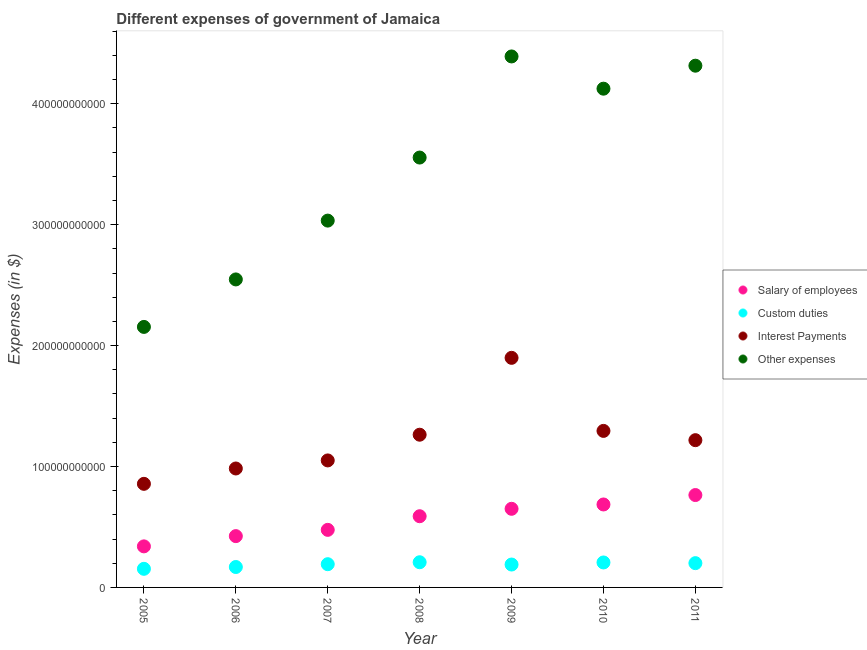How many different coloured dotlines are there?
Offer a very short reply. 4. Is the number of dotlines equal to the number of legend labels?
Offer a terse response. Yes. What is the amount spent on salary of employees in 2009?
Keep it short and to the point. 6.50e+1. Across all years, what is the maximum amount spent on other expenses?
Your response must be concise. 4.39e+11. Across all years, what is the minimum amount spent on interest payments?
Give a very brief answer. 8.57e+1. What is the total amount spent on interest payments in the graph?
Offer a very short reply. 8.56e+11. What is the difference between the amount spent on salary of employees in 2006 and that in 2011?
Your response must be concise. -3.40e+1. What is the difference between the amount spent on custom duties in 2010 and the amount spent on salary of employees in 2006?
Your answer should be compact. -2.18e+1. What is the average amount spent on salary of employees per year?
Give a very brief answer. 5.61e+1. In the year 2010, what is the difference between the amount spent on salary of employees and amount spent on other expenses?
Your answer should be compact. -3.44e+11. What is the ratio of the amount spent on interest payments in 2009 to that in 2011?
Give a very brief answer. 1.56. Is the difference between the amount spent on other expenses in 2007 and 2008 greater than the difference between the amount spent on salary of employees in 2007 and 2008?
Your answer should be compact. No. What is the difference between the highest and the second highest amount spent on custom duties?
Ensure brevity in your answer.  1.80e+08. What is the difference between the highest and the lowest amount spent on other expenses?
Offer a terse response. 2.24e+11. In how many years, is the amount spent on custom duties greater than the average amount spent on custom duties taken over all years?
Provide a succinct answer. 5. Is it the case that in every year, the sum of the amount spent on salary of employees and amount spent on custom duties is greater than the amount spent on interest payments?
Provide a succinct answer. No. Is the amount spent on other expenses strictly greater than the amount spent on custom duties over the years?
Your response must be concise. Yes. How many years are there in the graph?
Your answer should be compact. 7. What is the difference between two consecutive major ticks on the Y-axis?
Provide a succinct answer. 1.00e+11. Does the graph contain any zero values?
Ensure brevity in your answer.  No. How are the legend labels stacked?
Make the answer very short. Vertical. What is the title of the graph?
Your answer should be compact. Different expenses of government of Jamaica. What is the label or title of the X-axis?
Give a very brief answer. Year. What is the label or title of the Y-axis?
Your answer should be compact. Expenses (in $). What is the Expenses (in $) in Salary of employees in 2005?
Offer a very short reply. 3.39e+1. What is the Expenses (in $) of Custom duties in 2005?
Give a very brief answer. 1.54e+1. What is the Expenses (in $) in Interest Payments in 2005?
Ensure brevity in your answer.  8.57e+1. What is the Expenses (in $) in Other expenses in 2005?
Ensure brevity in your answer.  2.15e+11. What is the Expenses (in $) in Salary of employees in 2006?
Offer a very short reply. 4.24e+1. What is the Expenses (in $) in Custom duties in 2006?
Offer a terse response. 1.69e+1. What is the Expenses (in $) in Interest Payments in 2006?
Offer a very short reply. 9.84e+1. What is the Expenses (in $) of Other expenses in 2006?
Your answer should be very brief. 2.55e+11. What is the Expenses (in $) of Salary of employees in 2007?
Provide a short and direct response. 4.76e+1. What is the Expenses (in $) in Custom duties in 2007?
Your response must be concise. 1.92e+1. What is the Expenses (in $) of Interest Payments in 2007?
Your response must be concise. 1.05e+11. What is the Expenses (in $) of Other expenses in 2007?
Keep it short and to the point. 3.03e+11. What is the Expenses (in $) of Salary of employees in 2008?
Your response must be concise. 5.89e+1. What is the Expenses (in $) in Custom duties in 2008?
Make the answer very short. 2.08e+1. What is the Expenses (in $) of Interest Payments in 2008?
Your answer should be compact. 1.26e+11. What is the Expenses (in $) in Other expenses in 2008?
Give a very brief answer. 3.55e+11. What is the Expenses (in $) in Salary of employees in 2009?
Your answer should be compact. 6.50e+1. What is the Expenses (in $) in Custom duties in 2009?
Provide a short and direct response. 1.89e+1. What is the Expenses (in $) of Interest Payments in 2009?
Your response must be concise. 1.90e+11. What is the Expenses (in $) of Other expenses in 2009?
Offer a terse response. 4.39e+11. What is the Expenses (in $) in Salary of employees in 2010?
Offer a terse response. 6.86e+1. What is the Expenses (in $) of Custom duties in 2010?
Your answer should be compact. 2.06e+1. What is the Expenses (in $) of Interest Payments in 2010?
Offer a very short reply. 1.29e+11. What is the Expenses (in $) in Other expenses in 2010?
Your response must be concise. 4.12e+11. What is the Expenses (in $) of Salary of employees in 2011?
Your answer should be compact. 7.64e+1. What is the Expenses (in $) in Custom duties in 2011?
Provide a short and direct response. 2.01e+1. What is the Expenses (in $) in Interest Payments in 2011?
Offer a very short reply. 1.22e+11. What is the Expenses (in $) in Other expenses in 2011?
Offer a terse response. 4.31e+11. Across all years, what is the maximum Expenses (in $) of Salary of employees?
Provide a short and direct response. 7.64e+1. Across all years, what is the maximum Expenses (in $) of Custom duties?
Make the answer very short. 2.08e+1. Across all years, what is the maximum Expenses (in $) in Interest Payments?
Make the answer very short. 1.90e+11. Across all years, what is the maximum Expenses (in $) in Other expenses?
Make the answer very short. 4.39e+11. Across all years, what is the minimum Expenses (in $) in Salary of employees?
Your response must be concise. 3.39e+1. Across all years, what is the minimum Expenses (in $) in Custom duties?
Make the answer very short. 1.54e+1. Across all years, what is the minimum Expenses (in $) in Interest Payments?
Ensure brevity in your answer.  8.57e+1. Across all years, what is the minimum Expenses (in $) in Other expenses?
Provide a succinct answer. 2.15e+11. What is the total Expenses (in $) in Salary of employees in the graph?
Offer a terse response. 3.93e+11. What is the total Expenses (in $) of Custom duties in the graph?
Your response must be concise. 1.32e+11. What is the total Expenses (in $) in Interest Payments in the graph?
Offer a terse response. 8.56e+11. What is the total Expenses (in $) in Other expenses in the graph?
Keep it short and to the point. 2.41e+12. What is the difference between the Expenses (in $) of Salary of employees in 2005 and that in 2006?
Provide a short and direct response. -8.48e+09. What is the difference between the Expenses (in $) of Custom duties in 2005 and that in 2006?
Make the answer very short. -1.49e+09. What is the difference between the Expenses (in $) of Interest Payments in 2005 and that in 2006?
Offer a terse response. -1.27e+1. What is the difference between the Expenses (in $) of Other expenses in 2005 and that in 2006?
Provide a short and direct response. -3.93e+1. What is the difference between the Expenses (in $) in Salary of employees in 2005 and that in 2007?
Your answer should be compact. -1.37e+1. What is the difference between the Expenses (in $) of Custom duties in 2005 and that in 2007?
Your answer should be very brief. -3.82e+09. What is the difference between the Expenses (in $) of Interest Payments in 2005 and that in 2007?
Keep it short and to the point. -1.94e+1. What is the difference between the Expenses (in $) of Other expenses in 2005 and that in 2007?
Your answer should be very brief. -8.79e+1. What is the difference between the Expenses (in $) in Salary of employees in 2005 and that in 2008?
Offer a very short reply. -2.49e+1. What is the difference between the Expenses (in $) in Custom duties in 2005 and that in 2008?
Your response must be concise. -5.44e+09. What is the difference between the Expenses (in $) in Interest Payments in 2005 and that in 2008?
Provide a succinct answer. -4.06e+1. What is the difference between the Expenses (in $) in Other expenses in 2005 and that in 2008?
Make the answer very short. -1.40e+11. What is the difference between the Expenses (in $) in Salary of employees in 2005 and that in 2009?
Your answer should be very brief. -3.11e+1. What is the difference between the Expenses (in $) in Custom duties in 2005 and that in 2009?
Provide a succinct answer. -3.54e+09. What is the difference between the Expenses (in $) of Interest Payments in 2005 and that in 2009?
Your answer should be compact. -1.04e+11. What is the difference between the Expenses (in $) of Other expenses in 2005 and that in 2009?
Ensure brevity in your answer.  -2.24e+11. What is the difference between the Expenses (in $) of Salary of employees in 2005 and that in 2010?
Your answer should be compact. -3.47e+1. What is the difference between the Expenses (in $) in Custom duties in 2005 and that in 2010?
Provide a succinct answer. -5.26e+09. What is the difference between the Expenses (in $) of Interest Payments in 2005 and that in 2010?
Your answer should be very brief. -4.38e+1. What is the difference between the Expenses (in $) of Other expenses in 2005 and that in 2010?
Give a very brief answer. -1.97e+11. What is the difference between the Expenses (in $) of Salary of employees in 2005 and that in 2011?
Your answer should be compact. -4.24e+1. What is the difference between the Expenses (in $) in Custom duties in 2005 and that in 2011?
Your response must be concise. -4.69e+09. What is the difference between the Expenses (in $) in Interest Payments in 2005 and that in 2011?
Ensure brevity in your answer.  -3.61e+1. What is the difference between the Expenses (in $) of Other expenses in 2005 and that in 2011?
Offer a terse response. -2.16e+11. What is the difference between the Expenses (in $) in Salary of employees in 2006 and that in 2007?
Your answer should be compact. -5.18e+09. What is the difference between the Expenses (in $) in Custom duties in 2006 and that in 2007?
Give a very brief answer. -2.33e+09. What is the difference between the Expenses (in $) of Interest Payments in 2006 and that in 2007?
Provide a succinct answer. -6.67e+09. What is the difference between the Expenses (in $) of Other expenses in 2006 and that in 2007?
Offer a terse response. -4.86e+1. What is the difference between the Expenses (in $) in Salary of employees in 2006 and that in 2008?
Give a very brief answer. -1.64e+1. What is the difference between the Expenses (in $) of Custom duties in 2006 and that in 2008?
Ensure brevity in your answer.  -3.94e+09. What is the difference between the Expenses (in $) in Interest Payments in 2006 and that in 2008?
Your answer should be compact. -2.79e+1. What is the difference between the Expenses (in $) of Other expenses in 2006 and that in 2008?
Your answer should be compact. -1.01e+11. What is the difference between the Expenses (in $) in Salary of employees in 2006 and that in 2009?
Keep it short and to the point. -2.26e+1. What is the difference between the Expenses (in $) of Custom duties in 2006 and that in 2009?
Ensure brevity in your answer.  -2.05e+09. What is the difference between the Expenses (in $) of Interest Payments in 2006 and that in 2009?
Your answer should be compact. -9.15e+1. What is the difference between the Expenses (in $) in Other expenses in 2006 and that in 2009?
Your answer should be very brief. -1.84e+11. What is the difference between the Expenses (in $) in Salary of employees in 2006 and that in 2010?
Offer a very short reply. -2.62e+1. What is the difference between the Expenses (in $) in Custom duties in 2006 and that in 2010?
Your answer should be very brief. -3.76e+09. What is the difference between the Expenses (in $) in Interest Payments in 2006 and that in 2010?
Your answer should be compact. -3.11e+1. What is the difference between the Expenses (in $) in Other expenses in 2006 and that in 2010?
Offer a terse response. -1.58e+11. What is the difference between the Expenses (in $) in Salary of employees in 2006 and that in 2011?
Provide a short and direct response. -3.40e+1. What is the difference between the Expenses (in $) of Custom duties in 2006 and that in 2011?
Offer a very short reply. -3.19e+09. What is the difference between the Expenses (in $) of Interest Payments in 2006 and that in 2011?
Offer a very short reply. -2.34e+1. What is the difference between the Expenses (in $) in Other expenses in 2006 and that in 2011?
Give a very brief answer. -1.77e+11. What is the difference between the Expenses (in $) in Salary of employees in 2007 and that in 2008?
Ensure brevity in your answer.  -1.13e+1. What is the difference between the Expenses (in $) of Custom duties in 2007 and that in 2008?
Your answer should be very brief. -1.62e+09. What is the difference between the Expenses (in $) of Interest Payments in 2007 and that in 2008?
Your answer should be compact. -2.13e+1. What is the difference between the Expenses (in $) in Other expenses in 2007 and that in 2008?
Provide a short and direct response. -5.21e+1. What is the difference between the Expenses (in $) in Salary of employees in 2007 and that in 2009?
Give a very brief answer. -1.74e+1. What is the difference between the Expenses (in $) of Custom duties in 2007 and that in 2009?
Make the answer very short. 2.75e+08. What is the difference between the Expenses (in $) of Interest Payments in 2007 and that in 2009?
Ensure brevity in your answer.  -8.48e+1. What is the difference between the Expenses (in $) in Other expenses in 2007 and that in 2009?
Give a very brief answer. -1.36e+11. What is the difference between the Expenses (in $) of Salary of employees in 2007 and that in 2010?
Offer a very short reply. -2.10e+1. What is the difference between the Expenses (in $) of Custom duties in 2007 and that in 2010?
Offer a very short reply. -1.44e+09. What is the difference between the Expenses (in $) of Interest Payments in 2007 and that in 2010?
Offer a terse response. -2.44e+1. What is the difference between the Expenses (in $) of Other expenses in 2007 and that in 2010?
Offer a terse response. -1.09e+11. What is the difference between the Expenses (in $) of Salary of employees in 2007 and that in 2011?
Offer a terse response. -2.88e+1. What is the difference between the Expenses (in $) of Custom duties in 2007 and that in 2011?
Ensure brevity in your answer.  -8.66e+08. What is the difference between the Expenses (in $) of Interest Payments in 2007 and that in 2011?
Provide a succinct answer. -1.67e+1. What is the difference between the Expenses (in $) of Other expenses in 2007 and that in 2011?
Provide a short and direct response. -1.28e+11. What is the difference between the Expenses (in $) in Salary of employees in 2008 and that in 2009?
Your answer should be very brief. -6.14e+09. What is the difference between the Expenses (in $) of Custom duties in 2008 and that in 2009?
Offer a terse response. 1.89e+09. What is the difference between the Expenses (in $) of Interest Payments in 2008 and that in 2009?
Provide a succinct answer. -6.36e+1. What is the difference between the Expenses (in $) of Other expenses in 2008 and that in 2009?
Make the answer very short. -8.36e+1. What is the difference between the Expenses (in $) of Salary of employees in 2008 and that in 2010?
Your answer should be very brief. -9.73e+09. What is the difference between the Expenses (in $) in Custom duties in 2008 and that in 2010?
Make the answer very short. 1.80e+08. What is the difference between the Expenses (in $) in Interest Payments in 2008 and that in 2010?
Offer a terse response. -3.15e+09. What is the difference between the Expenses (in $) in Other expenses in 2008 and that in 2010?
Your answer should be very brief. -5.69e+1. What is the difference between the Expenses (in $) of Salary of employees in 2008 and that in 2011?
Give a very brief answer. -1.75e+1. What is the difference between the Expenses (in $) in Custom duties in 2008 and that in 2011?
Offer a terse response. 7.50e+08. What is the difference between the Expenses (in $) in Interest Payments in 2008 and that in 2011?
Ensure brevity in your answer.  4.51e+09. What is the difference between the Expenses (in $) of Other expenses in 2008 and that in 2011?
Make the answer very short. -7.60e+1. What is the difference between the Expenses (in $) of Salary of employees in 2009 and that in 2010?
Ensure brevity in your answer.  -3.59e+09. What is the difference between the Expenses (in $) in Custom duties in 2009 and that in 2010?
Your answer should be very brief. -1.71e+09. What is the difference between the Expenses (in $) in Interest Payments in 2009 and that in 2010?
Give a very brief answer. 6.04e+1. What is the difference between the Expenses (in $) in Other expenses in 2009 and that in 2010?
Ensure brevity in your answer.  2.67e+1. What is the difference between the Expenses (in $) in Salary of employees in 2009 and that in 2011?
Ensure brevity in your answer.  -1.14e+1. What is the difference between the Expenses (in $) in Custom duties in 2009 and that in 2011?
Your answer should be compact. -1.14e+09. What is the difference between the Expenses (in $) in Interest Payments in 2009 and that in 2011?
Offer a very short reply. 6.81e+1. What is the difference between the Expenses (in $) in Other expenses in 2009 and that in 2011?
Keep it short and to the point. 7.65e+09. What is the difference between the Expenses (in $) in Salary of employees in 2010 and that in 2011?
Make the answer very short. -7.79e+09. What is the difference between the Expenses (in $) in Custom duties in 2010 and that in 2011?
Your answer should be compact. 5.70e+08. What is the difference between the Expenses (in $) of Interest Payments in 2010 and that in 2011?
Your answer should be compact. 7.67e+09. What is the difference between the Expenses (in $) of Other expenses in 2010 and that in 2011?
Your response must be concise. -1.90e+1. What is the difference between the Expenses (in $) in Salary of employees in 2005 and the Expenses (in $) in Custom duties in 2006?
Give a very brief answer. 1.71e+1. What is the difference between the Expenses (in $) in Salary of employees in 2005 and the Expenses (in $) in Interest Payments in 2006?
Provide a succinct answer. -6.44e+1. What is the difference between the Expenses (in $) of Salary of employees in 2005 and the Expenses (in $) of Other expenses in 2006?
Ensure brevity in your answer.  -2.21e+11. What is the difference between the Expenses (in $) in Custom duties in 2005 and the Expenses (in $) in Interest Payments in 2006?
Your response must be concise. -8.30e+1. What is the difference between the Expenses (in $) of Custom duties in 2005 and the Expenses (in $) of Other expenses in 2006?
Provide a short and direct response. -2.39e+11. What is the difference between the Expenses (in $) of Interest Payments in 2005 and the Expenses (in $) of Other expenses in 2006?
Give a very brief answer. -1.69e+11. What is the difference between the Expenses (in $) of Salary of employees in 2005 and the Expenses (in $) of Custom duties in 2007?
Make the answer very short. 1.47e+1. What is the difference between the Expenses (in $) in Salary of employees in 2005 and the Expenses (in $) in Interest Payments in 2007?
Make the answer very short. -7.11e+1. What is the difference between the Expenses (in $) of Salary of employees in 2005 and the Expenses (in $) of Other expenses in 2007?
Your answer should be very brief. -2.69e+11. What is the difference between the Expenses (in $) of Custom duties in 2005 and the Expenses (in $) of Interest Payments in 2007?
Your answer should be very brief. -8.96e+1. What is the difference between the Expenses (in $) of Custom duties in 2005 and the Expenses (in $) of Other expenses in 2007?
Keep it short and to the point. -2.88e+11. What is the difference between the Expenses (in $) in Interest Payments in 2005 and the Expenses (in $) in Other expenses in 2007?
Provide a short and direct response. -2.18e+11. What is the difference between the Expenses (in $) of Salary of employees in 2005 and the Expenses (in $) of Custom duties in 2008?
Provide a succinct answer. 1.31e+1. What is the difference between the Expenses (in $) in Salary of employees in 2005 and the Expenses (in $) in Interest Payments in 2008?
Give a very brief answer. -9.23e+1. What is the difference between the Expenses (in $) in Salary of employees in 2005 and the Expenses (in $) in Other expenses in 2008?
Give a very brief answer. -3.22e+11. What is the difference between the Expenses (in $) of Custom duties in 2005 and the Expenses (in $) of Interest Payments in 2008?
Offer a very short reply. -1.11e+11. What is the difference between the Expenses (in $) in Custom duties in 2005 and the Expenses (in $) in Other expenses in 2008?
Make the answer very short. -3.40e+11. What is the difference between the Expenses (in $) in Interest Payments in 2005 and the Expenses (in $) in Other expenses in 2008?
Provide a succinct answer. -2.70e+11. What is the difference between the Expenses (in $) of Salary of employees in 2005 and the Expenses (in $) of Custom duties in 2009?
Ensure brevity in your answer.  1.50e+1. What is the difference between the Expenses (in $) of Salary of employees in 2005 and the Expenses (in $) of Interest Payments in 2009?
Your response must be concise. -1.56e+11. What is the difference between the Expenses (in $) in Salary of employees in 2005 and the Expenses (in $) in Other expenses in 2009?
Offer a very short reply. -4.05e+11. What is the difference between the Expenses (in $) of Custom duties in 2005 and the Expenses (in $) of Interest Payments in 2009?
Give a very brief answer. -1.74e+11. What is the difference between the Expenses (in $) in Custom duties in 2005 and the Expenses (in $) in Other expenses in 2009?
Provide a short and direct response. -4.24e+11. What is the difference between the Expenses (in $) in Interest Payments in 2005 and the Expenses (in $) in Other expenses in 2009?
Your answer should be very brief. -3.53e+11. What is the difference between the Expenses (in $) in Salary of employees in 2005 and the Expenses (in $) in Custom duties in 2010?
Your answer should be compact. 1.33e+1. What is the difference between the Expenses (in $) in Salary of employees in 2005 and the Expenses (in $) in Interest Payments in 2010?
Make the answer very short. -9.55e+1. What is the difference between the Expenses (in $) of Salary of employees in 2005 and the Expenses (in $) of Other expenses in 2010?
Make the answer very short. -3.78e+11. What is the difference between the Expenses (in $) of Custom duties in 2005 and the Expenses (in $) of Interest Payments in 2010?
Offer a very short reply. -1.14e+11. What is the difference between the Expenses (in $) of Custom duties in 2005 and the Expenses (in $) of Other expenses in 2010?
Your response must be concise. -3.97e+11. What is the difference between the Expenses (in $) in Interest Payments in 2005 and the Expenses (in $) in Other expenses in 2010?
Your answer should be compact. -3.27e+11. What is the difference between the Expenses (in $) of Salary of employees in 2005 and the Expenses (in $) of Custom duties in 2011?
Provide a short and direct response. 1.39e+1. What is the difference between the Expenses (in $) in Salary of employees in 2005 and the Expenses (in $) in Interest Payments in 2011?
Provide a succinct answer. -8.78e+1. What is the difference between the Expenses (in $) of Salary of employees in 2005 and the Expenses (in $) of Other expenses in 2011?
Provide a short and direct response. -3.97e+11. What is the difference between the Expenses (in $) of Custom duties in 2005 and the Expenses (in $) of Interest Payments in 2011?
Your answer should be compact. -1.06e+11. What is the difference between the Expenses (in $) in Custom duties in 2005 and the Expenses (in $) in Other expenses in 2011?
Your answer should be very brief. -4.16e+11. What is the difference between the Expenses (in $) in Interest Payments in 2005 and the Expenses (in $) in Other expenses in 2011?
Offer a terse response. -3.46e+11. What is the difference between the Expenses (in $) of Salary of employees in 2006 and the Expenses (in $) of Custom duties in 2007?
Your answer should be very brief. 2.32e+1. What is the difference between the Expenses (in $) of Salary of employees in 2006 and the Expenses (in $) of Interest Payments in 2007?
Keep it short and to the point. -6.26e+1. What is the difference between the Expenses (in $) of Salary of employees in 2006 and the Expenses (in $) of Other expenses in 2007?
Offer a very short reply. -2.61e+11. What is the difference between the Expenses (in $) of Custom duties in 2006 and the Expenses (in $) of Interest Payments in 2007?
Provide a succinct answer. -8.81e+1. What is the difference between the Expenses (in $) in Custom duties in 2006 and the Expenses (in $) in Other expenses in 2007?
Your answer should be very brief. -2.86e+11. What is the difference between the Expenses (in $) in Interest Payments in 2006 and the Expenses (in $) in Other expenses in 2007?
Your answer should be very brief. -2.05e+11. What is the difference between the Expenses (in $) of Salary of employees in 2006 and the Expenses (in $) of Custom duties in 2008?
Make the answer very short. 2.16e+1. What is the difference between the Expenses (in $) of Salary of employees in 2006 and the Expenses (in $) of Interest Payments in 2008?
Your answer should be very brief. -8.39e+1. What is the difference between the Expenses (in $) in Salary of employees in 2006 and the Expenses (in $) in Other expenses in 2008?
Your answer should be very brief. -3.13e+11. What is the difference between the Expenses (in $) of Custom duties in 2006 and the Expenses (in $) of Interest Payments in 2008?
Your response must be concise. -1.09e+11. What is the difference between the Expenses (in $) of Custom duties in 2006 and the Expenses (in $) of Other expenses in 2008?
Keep it short and to the point. -3.39e+11. What is the difference between the Expenses (in $) in Interest Payments in 2006 and the Expenses (in $) in Other expenses in 2008?
Your answer should be compact. -2.57e+11. What is the difference between the Expenses (in $) of Salary of employees in 2006 and the Expenses (in $) of Custom duties in 2009?
Ensure brevity in your answer.  2.35e+1. What is the difference between the Expenses (in $) of Salary of employees in 2006 and the Expenses (in $) of Interest Payments in 2009?
Your answer should be compact. -1.47e+11. What is the difference between the Expenses (in $) of Salary of employees in 2006 and the Expenses (in $) of Other expenses in 2009?
Your answer should be compact. -3.97e+11. What is the difference between the Expenses (in $) of Custom duties in 2006 and the Expenses (in $) of Interest Payments in 2009?
Your answer should be compact. -1.73e+11. What is the difference between the Expenses (in $) of Custom duties in 2006 and the Expenses (in $) of Other expenses in 2009?
Offer a very short reply. -4.22e+11. What is the difference between the Expenses (in $) of Interest Payments in 2006 and the Expenses (in $) of Other expenses in 2009?
Your answer should be compact. -3.41e+11. What is the difference between the Expenses (in $) in Salary of employees in 2006 and the Expenses (in $) in Custom duties in 2010?
Offer a very short reply. 2.18e+1. What is the difference between the Expenses (in $) in Salary of employees in 2006 and the Expenses (in $) in Interest Payments in 2010?
Provide a short and direct response. -8.70e+1. What is the difference between the Expenses (in $) in Salary of employees in 2006 and the Expenses (in $) in Other expenses in 2010?
Your answer should be very brief. -3.70e+11. What is the difference between the Expenses (in $) in Custom duties in 2006 and the Expenses (in $) in Interest Payments in 2010?
Your response must be concise. -1.13e+11. What is the difference between the Expenses (in $) in Custom duties in 2006 and the Expenses (in $) in Other expenses in 2010?
Your answer should be compact. -3.96e+11. What is the difference between the Expenses (in $) of Interest Payments in 2006 and the Expenses (in $) of Other expenses in 2010?
Give a very brief answer. -3.14e+11. What is the difference between the Expenses (in $) in Salary of employees in 2006 and the Expenses (in $) in Custom duties in 2011?
Offer a terse response. 2.24e+1. What is the difference between the Expenses (in $) in Salary of employees in 2006 and the Expenses (in $) in Interest Payments in 2011?
Offer a terse response. -7.93e+1. What is the difference between the Expenses (in $) of Salary of employees in 2006 and the Expenses (in $) of Other expenses in 2011?
Your response must be concise. -3.89e+11. What is the difference between the Expenses (in $) of Custom duties in 2006 and the Expenses (in $) of Interest Payments in 2011?
Provide a succinct answer. -1.05e+11. What is the difference between the Expenses (in $) of Custom duties in 2006 and the Expenses (in $) of Other expenses in 2011?
Ensure brevity in your answer.  -4.15e+11. What is the difference between the Expenses (in $) in Interest Payments in 2006 and the Expenses (in $) in Other expenses in 2011?
Give a very brief answer. -3.33e+11. What is the difference between the Expenses (in $) in Salary of employees in 2007 and the Expenses (in $) in Custom duties in 2008?
Your answer should be compact. 2.68e+1. What is the difference between the Expenses (in $) of Salary of employees in 2007 and the Expenses (in $) of Interest Payments in 2008?
Provide a succinct answer. -7.87e+1. What is the difference between the Expenses (in $) in Salary of employees in 2007 and the Expenses (in $) in Other expenses in 2008?
Make the answer very short. -3.08e+11. What is the difference between the Expenses (in $) in Custom duties in 2007 and the Expenses (in $) in Interest Payments in 2008?
Offer a very short reply. -1.07e+11. What is the difference between the Expenses (in $) of Custom duties in 2007 and the Expenses (in $) of Other expenses in 2008?
Offer a very short reply. -3.36e+11. What is the difference between the Expenses (in $) in Interest Payments in 2007 and the Expenses (in $) in Other expenses in 2008?
Make the answer very short. -2.50e+11. What is the difference between the Expenses (in $) in Salary of employees in 2007 and the Expenses (in $) in Custom duties in 2009?
Your answer should be compact. 2.87e+1. What is the difference between the Expenses (in $) in Salary of employees in 2007 and the Expenses (in $) in Interest Payments in 2009?
Keep it short and to the point. -1.42e+11. What is the difference between the Expenses (in $) of Salary of employees in 2007 and the Expenses (in $) of Other expenses in 2009?
Keep it short and to the point. -3.91e+11. What is the difference between the Expenses (in $) in Custom duties in 2007 and the Expenses (in $) in Interest Payments in 2009?
Ensure brevity in your answer.  -1.71e+11. What is the difference between the Expenses (in $) in Custom duties in 2007 and the Expenses (in $) in Other expenses in 2009?
Ensure brevity in your answer.  -4.20e+11. What is the difference between the Expenses (in $) of Interest Payments in 2007 and the Expenses (in $) of Other expenses in 2009?
Your answer should be very brief. -3.34e+11. What is the difference between the Expenses (in $) of Salary of employees in 2007 and the Expenses (in $) of Custom duties in 2010?
Make the answer very short. 2.70e+1. What is the difference between the Expenses (in $) of Salary of employees in 2007 and the Expenses (in $) of Interest Payments in 2010?
Provide a succinct answer. -8.18e+1. What is the difference between the Expenses (in $) in Salary of employees in 2007 and the Expenses (in $) in Other expenses in 2010?
Your answer should be compact. -3.65e+11. What is the difference between the Expenses (in $) of Custom duties in 2007 and the Expenses (in $) of Interest Payments in 2010?
Ensure brevity in your answer.  -1.10e+11. What is the difference between the Expenses (in $) of Custom duties in 2007 and the Expenses (in $) of Other expenses in 2010?
Your answer should be very brief. -3.93e+11. What is the difference between the Expenses (in $) in Interest Payments in 2007 and the Expenses (in $) in Other expenses in 2010?
Offer a very short reply. -3.07e+11. What is the difference between the Expenses (in $) in Salary of employees in 2007 and the Expenses (in $) in Custom duties in 2011?
Provide a short and direct response. 2.75e+1. What is the difference between the Expenses (in $) of Salary of employees in 2007 and the Expenses (in $) of Interest Payments in 2011?
Keep it short and to the point. -7.42e+1. What is the difference between the Expenses (in $) in Salary of employees in 2007 and the Expenses (in $) in Other expenses in 2011?
Give a very brief answer. -3.84e+11. What is the difference between the Expenses (in $) of Custom duties in 2007 and the Expenses (in $) of Interest Payments in 2011?
Offer a terse response. -1.03e+11. What is the difference between the Expenses (in $) in Custom duties in 2007 and the Expenses (in $) in Other expenses in 2011?
Ensure brevity in your answer.  -4.12e+11. What is the difference between the Expenses (in $) in Interest Payments in 2007 and the Expenses (in $) in Other expenses in 2011?
Keep it short and to the point. -3.26e+11. What is the difference between the Expenses (in $) in Salary of employees in 2008 and the Expenses (in $) in Custom duties in 2009?
Provide a succinct answer. 3.99e+1. What is the difference between the Expenses (in $) of Salary of employees in 2008 and the Expenses (in $) of Interest Payments in 2009?
Offer a terse response. -1.31e+11. What is the difference between the Expenses (in $) of Salary of employees in 2008 and the Expenses (in $) of Other expenses in 2009?
Ensure brevity in your answer.  -3.80e+11. What is the difference between the Expenses (in $) in Custom duties in 2008 and the Expenses (in $) in Interest Payments in 2009?
Give a very brief answer. -1.69e+11. What is the difference between the Expenses (in $) in Custom duties in 2008 and the Expenses (in $) in Other expenses in 2009?
Make the answer very short. -4.18e+11. What is the difference between the Expenses (in $) in Interest Payments in 2008 and the Expenses (in $) in Other expenses in 2009?
Provide a succinct answer. -3.13e+11. What is the difference between the Expenses (in $) in Salary of employees in 2008 and the Expenses (in $) in Custom duties in 2010?
Give a very brief answer. 3.82e+1. What is the difference between the Expenses (in $) of Salary of employees in 2008 and the Expenses (in $) of Interest Payments in 2010?
Provide a succinct answer. -7.06e+1. What is the difference between the Expenses (in $) of Salary of employees in 2008 and the Expenses (in $) of Other expenses in 2010?
Make the answer very short. -3.54e+11. What is the difference between the Expenses (in $) of Custom duties in 2008 and the Expenses (in $) of Interest Payments in 2010?
Provide a succinct answer. -1.09e+11. What is the difference between the Expenses (in $) of Custom duties in 2008 and the Expenses (in $) of Other expenses in 2010?
Provide a short and direct response. -3.92e+11. What is the difference between the Expenses (in $) in Interest Payments in 2008 and the Expenses (in $) in Other expenses in 2010?
Provide a succinct answer. -2.86e+11. What is the difference between the Expenses (in $) in Salary of employees in 2008 and the Expenses (in $) in Custom duties in 2011?
Offer a very short reply. 3.88e+1. What is the difference between the Expenses (in $) of Salary of employees in 2008 and the Expenses (in $) of Interest Payments in 2011?
Make the answer very short. -6.29e+1. What is the difference between the Expenses (in $) in Salary of employees in 2008 and the Expenses (in $) in Other expenses in 2011?
Offer a very short reply. -3.73e+11. What is the difference between the Expenses (in $) of Custom duties in 2008 and the Expenses (in $) of Interest Payments in 2011?
Provide a succinct answer. -1.01e+11. What is the difference between the Expenses (in $) in Custom duties in 2008 and the Expenses (in $) in Other expenses in 2011?
Your response must be concise. -4.11e+11. What is the difference between the Expenses (in $) in Interest Payments in 2008 and the Expenses (in $) in Other expenses in 2011?
Keep it short and to the point. -3.05e+11. What is the difference between the Expenses (in $) in Salary of employees in 2009 and the Expenses (in $) in Custom duties in 2010?
Offer a terse response. 4.44e+1. What is the difference between the Expenses (in $) of Salary of employees in 2009 and the Expenses (in $) of Interest Payments in 2010?
Give a very brief answer. -6.44e+1. What is the difference between the Expenses (in $) of Salary of employees in 2009 and the Expenses (in $) of Other expenses in 2010?
Make the answer very short. -3.47e+11. What is the difference between the Expenses (in $) in Custom duties in 2009 and the Expenses (in $) in Interest Payments in 2010?
Offer a very short reply. -1.11e+11. What is the difference between the Expenses (in $) of Custom duties in 2009 and the Expenses (in $) of Other expenses in 2010?
Offer a terse response. -3.93e+11. What is the difference between the Expenses (in $) in Interest Payments in 2009 and the Expenses (in $) in Other expenses in 2010?
Make the answer very short. -2.23e+11. What is the difference between the Expenses (in $) in Salary of employees in 2009 and the Expenses (in $) in Custom duties in 2011?
Ensure brevity in your answer.  4.49e+1. What is the difference between the Expenses (in $) in Salary of employees in 2009 and the Expenses (in $) in Interest Payments in 2011?
Your response must be concise. -5.68e+1. What is the difference between the Expenses (in $) of Salary of employees in 2009 and the Expenses (in $) of Other expenses in 2011?
Your answer should be compact. -3.66e+11. What is the difference between the Expenses (in $) in Custom duties in 2009 and the Expenses (in $) in Interest Payments in 2011?
Offer a terse response. -1.03e+11. What is the difference between the Expenses (in $) in Custom duties in 2009 and the Expenses (in $) in Other expenses in 2011?
Make the answer very short. -4.13e+11. What is the difference between the Expenses (in $) in Interest Payments in 2009 and the Expenses (in $) in Other expenses in 2011?
Ensure brevity in your answer.  -2.42e+11. What is the difference between the Expenses (in $) in Salary of employees in 2010 and the Expenses (in $) in Custom duties in 2011?
Your answer should be very brief. 4.85e+1. What is the difference between the Expenses (in $) in Salary of employees in 2010 and the Expenses (in $) in Interest Payments in 2011?
Your answer should be very brief. -5.32e+1. What is the difference between the Expenses (in $) in Salary of employees in 2010 and the Expenses (in $) in Other expenses in 2011?
Provide a succinct answer. -3.63e+11. What is the difference between the Expenses (in $) of Custom duties in 2010 and the Expenses (in $) of Interest Payments in 2011?
Ensure brevity in your answer.  -1.01e+11. What is the difference between the Expenses (in $) of Custom duties in 2010 and the Expenses (in $) of Other expenses in 2011?
Offer a terse response. -4.11e+11. What is the difference between the Expenses (in $) of Interest Payments in 2010 and the Expenses (in $) of Other expenses in 2011?
Provide a succinct answer. -3.02e+11. What is the average Expenses (in $) in Salary of employees per year?
Offer a terse response. 5.61e+1. What is the average Expenses (in $) in Custom duties per year?
Make the answer very short. 1.88e+1. What is the average Expenses (in $) of Interest Payments per year?
Make the answer very short. 1.22e+11. What is the average Expenses (in $) in Other expenses per year?
Make the answer very short. 3.45e+11. In the year 2005, what is the difference between the Expenses (in $) in Salary of employees and Expenses (in $) in Custom duties?
Offer a terse response. 1.86e+1. In the year 2005, what is the difference between the Expenses (in $) in Salary of employees and Expenses (in $) in Interest Payments?
Make the answer very short. -5.17e+1. In the year 2005, what is the difference between the Expenses (in $) in Salary of employees and Expenses (in $) in Other expenses?
Your answer should be compact. -1.81e+11. In the year 2005, what is the difference between the Expenses (in $) in Custom duties and Expenses (in $) in Interest Payments?
Keep it short and to the point. -7.03e+1. In the year 2005, what is the difference between the Expenses (in $) of Custom duties and Expenses (in $) of Other expenses?
Keep it short and to the point. -2.00e+11. In the year 2005, what is the difference between the Expenses (in $) in Interest Payments and Expenses (in $) in Other expenses?
Ensure brevity in your answer.  -1.30e+11. In the year 2006, what is the difference between the Expenses (in $) in Salary of employees and Expenses (in $) in Custom duties?
Offer a terse response. 2.55e+1. In the year 2006, what is the difference between the Expenses (in $) in Salary of employees and Expenses (in $) in Interest Payments?
Offer a terse response. -5.59e+1. In the year 2006, what is the difference between the Expenses (in $) of Salary of employees and Expenses (in $) of Other expenses?
Give a very brief answer. -2.12e+11. In the year 2006, what is the difference between the Expenses (in $) of Custom duties and Expenses (in $) of Interest Payments?
Keep it short and to the point. -8.15e+1. In the year 2006, what is the difference between the Expenses (in $) of Custom duties and Expenses (in $) of Other expenses?
Your response must be concise. -2.38e+11. In the year 2006, what is the difference between the Expenses (in $) in Interest Payments and Expenses (in $) in Other expenses?
Keep it short and to the point. -1.56e+11. In the year 2007, what is the difference between the Expenses (in $) of Salary of employees and Expenses (in $) of Custom duties?
Ensure brevity in your answer.  2.84e+1. In the year 2007, what is the difference between the Expenses (in $) in Salary of employees and Expenses (in $) in Interest Payments?
Your answer should be very brief. -5.74e+1. In the year 2007, what is the difference between the Expenses (in $) of Salary of employees and Expenses (in $) of Other expenses?
Your answer should be compact. -2.56e+11. In the year 2007, what is the difference between the Expenses (in $) in Custom duties and Expenses (in $) in Interest Payments?
Offer a terse response. -8.58e+1. In the year 2007, what is the difference between the Expenses (in $) in Custom duties and Expenses (in $) in Other expenses?
Provide a short and direct response. -2.84e+11. In the year 2007, what is the difference between the Expenses (in $) of Interest Payments and Expenses (in $) of Other expenses?
Keep it short and to the point. -1.98e+11. In the year 2008, what is the difference between the Expenses (in $) in Salary of employees and Expenses (in $) in Custom duties?
Your answer should be very brief. 3.81e+1. In the year 2008, what is the difference between the Expenses (in $) in Salary of employees and Expenses (in $) in Interest Payments?
Offer a very short reply. -6.74e+1. In the year 2008, what is the difference between the Expenses (in $) of Salary of employees and Expenses (in $) of Other expenses?
Ensure brevity in your answer.  -2.97e+11. In the year 2008, what is the difference between the Expenses (in $) in Custom duties and Expenses (in $) in Interest Payments?
Give a very brief answer. -1.05e+11. In the year 2008, what is the difference between the Expenses (in $) in Custom duties and Expenses (in $) in Other expenses?
Provide a succinct answer. -3.35e+11. In the year 2008, what is the difference between the Expenses (in $) in Interest Payments and Expenses (in $) in Other expenses?
Offer a terse response. -2.29e+11. In the year 2009, what is the difference between the Expenses (in $) in Salary of employees and Expenses (in $) in Custom duties?
Ensure brevity in your answer.  4.61e+1. In the year 2009, what is the difference between the Expenses (in $) in Salary of employees and Expenses (in $) in Interest Payments?
Offer a very short reply. -1.25e+11. In the year 2009, what is the difference between the Expenses (in $) of Salary of employees and Expenses (in $) of Other expenses?
Your response must be concise. -3.74e+11. In the year 2009, what is the difference between the Expenses (in $) of Custom duties and Expenses (in $) of Interest Payments?
Provide a short and direct response. -1.71e+11. In the year 2009, what is the difference between the Expenses (in $) in Custom duties and Expenses (in $) in Other expenses?
Offer a terse response. -4.20e+11. In the year 2009, what is the difference between the Expenses (in $) of Interest Payments and Expenses (in $) of Other expenses?
Provide a short and direct response. -2.49e+11. In the year 2010, what is the difference between the Expenses (in $) in Salary of employees and Expenses (in $) in Custom duties?
Keep it short and to the point. 4.80e+1. In the year 2010, what is the difference between the Expenses (in $) in Salary of employees and Expenses (in $) in Interest Payments?
Make the answer very short. -6.08e+1. In the year 2010, what is the difference between the Expenses (in $) of Salary of employees and Expenses (in $) of Other expenses?
Your response must be concise. -3.44e+11. In the year 2010, what is the difference between the Expenses (in $) of Custom duties and Expenses (in $) of Interest Payments?
Make the answer very short. -1.09e+11. In the year 2010, what is the difference between the Expenses (in $) in Custom duties and Expenses (in $) in Other expenses?
Give a very brief answer. -3.92e+11. In the year 2010, what is the difference between the Expenses (in $) in Interest Payments and Expenses (in $) in Other expenses?
Keep it short and to the point. -2.83e+11. In the year 2011, what is the difference between the Expenses (in $) in Salary of employees and Expenses (in $) in Custom duties?
Your answer should be compact. 5.63e+1. In the year 2011, what is the difference between the Expenses (in $) in Salary of employees and Expenses (in $) in Interest Payments?
Your answer should be compact. -4.54e+1. In the year 2011, what is the difference between the Expenses (in $) in Salary of employees and Expenses (in $) in Other expenses?
Provide a short and direct response. -3.55e+11. In the year 2011, what is the difference between the Expenses (in $) in Custom duties and Expenses (in $) in Interest Payments?
Provide a succinct answer. -1.02e+11. In the year 2011, what is the difference between the Expenses (in $) of Custom duties and Expenses (in $) of Other expenses?
Keep it short and to the point. -4.11e+11. In the year 2011, what is the difference between the Expenses (in $) in Interest Payments and Expenses (in $) in Other expenses?
Ensure brevity in your answer.  -3.10e+11. What is the ratio of the Expenses (in $) of Salary of employees in 2005 to that in 2006?
Your answer should be very brief. 0.8. What is the ratio of the Expenses (in $) in Custom duties in 2005 to that in 2006?
Provide a succinct answer. 0.91. What is the ratio of the Expenses (in $) in Interest Payments in 2005 to that in 2006?
Keep it short and to the point. 0.87. What is the ratio of the Expenses (in $) of Other expenses in 2005 to that in 2006?
Your answer should be compact. 0.85. What is the ratio of the Expenses (in $) in Salary of employees in 2005 to that in 2007?
Provide a short and direct response. 0.71. What is the ratio of the Expenses (in $) of Custom duties in 2005 to that in 2007?
Provide a short and direct response. 0.8. What is the ratio of the Expenses (in $) in Interest Payments in 2005 to that in 2007?
Your answer should be very brief. 0.82. What is the ratio of the Expenses (in $) of Other expenses in 2005 to that in 2007?
Provide a succinct answer. 0.71. What is the ratio of the Expenses (in $) in Salary of employees in 2005 to that in 2008?
Provide a succinct answer. 0.58. What is the ratio of the Expenses (in $) of Custom duties in 2005 to that in 2008?
Your answer should be compact. 0.74. What is the ratio of the Expenses (in $) in Interest Payments in 2005 to that in 2008?
Offer a very short reply. 0.68. What is the ratio of the Expenses (in $) in Other expenses in 2005 to that in 2008?
Ensure brevity in your answer.  0.61. What is the ratio of the Expenses (in $) in Salary of employees in 2005 to that in 2009?
Provide a succinct answer. 0.52. What is the ratio of the Expenses (in $) in Custom duties in 2005 to that in 2009?
Your response must be concise. 0.81. What is the ratio of the Expenses (in $) of Interest Payments in 2005 to that in 2009?
Your answer should be very brief. 0.45. What is the ratio of the Expenses (in $) in Other expenses in 2005 to that in 2009?
Ensure brevity in your answer.  0.49. What is the ratio of the Expenses (in $) in Salary of employees in 2005 to that in 2010?
Your answer should be compact. 0.49. What is the ratio of the Expenses (in $) of Custom duties in 2005 to that in 2010?
Make the answer very short. 0.75. What is the ratio of the Expenses (in $) in Interest Payments in 2005 to that in 2010?
Offer a very short reply. 0.66. What is the ratio of the Expenses (in $) of Other expenses in 2005 to that in 2010?
Provide a succinct answer. 0.52. What is the ratio of the Expenses (in $) in Salary of employees in 2005 to that in 2011?
Your answer should be very brief. 0.44. What is the ratio of the Expenses (in $) in Custom duties in 2005 to that in 2011?
Offer a very short reply. 0.77. What is the ratio of the Expenses (in $) in Interest Payments in 2005 to that in 2011?
Give a very brief answer. 0.7. What is the ratio of the Expenses (in $) of Other expenses in 2005 to that in 2011?
Your response must be concise. 0.5. What is the ratio of the Expenses (in $) in Salary of employees in 2006 to that in 2007?
Ensure brevity in your answer.  0.89. What is the ratio of the Expenses (in $) in Custom duties in 2006 to that in 2007?
Your response must be concise. 0.88. What is the ratio of the Expenses (in $) in Interest Payments in 2006 to that in 2007?
Your answer should be very brief. 0.94. What is the ratio of the Expenses (in $) in Other expenses in 2006 to that in 2007?
Make the answer very short. 0.84. What is the ratio of the Expenses (in $) of Salary of employees in 2006 to that in 2008?
Offer a terse response. 0.72. What is the ratio of the Expenses (in $) in Custom duties in 2006 to that in 2008?
Provide a succinct answer. 0.81. What is the ratio of the Expenses (in $) in Interest Payments in 2006 to that in 2008?
Make the answer very short. 0.78. What is the ratio of the Expenses (in $) in Other expenses in 2006 to that in 2008?
Offer a terse response. 0.72. What is the ratio of the Expenses (in $) in Salary of employees in 2006 to that in 2009?
Keep it short and to the point. 0.65. What is the ratio of the Expenses (in $) of Custom duties in 2006 to that in 2009?
Make the answer very short. 0.89. What is the ratio of the Expenses (in $) in Interest Payments in 2006 to that in 2009?
Your response must be concise. 0.52. What is the ratio of the Expenses (in $) of Other expenses in 2006 to that in 2009?
Provide a short and direct response. 0.58. What is the ratio of the Expenses (in $) of Salary of employees in 2006 to that in 2010?
Your answer should be very brief. 0.62. What is the ratio of the Expenses (in $) in Custom duties in 2006 to that in 2010?
Give a very brief answer. 0.82. What is the ratio of the Expenses (in $) in Interest Payments in 2006 to that in 2010?
Provide a short and direct response. 0.76. What is the ratio of the Expenses (in $) of Other expenses in 2006 to that in 2010?
Keep it short and to the point. 0.62. What is the ratio of the Expenses (in $) of Salary of employees in 2006 to that in 2011?
Give a very brief answer. 0.56. What is the ratio of the Expenses (in $) in Custom duties in 2006 to that in 2011?
Offer a very short reply. 0.84. What is the ratio of the Expenses (in $) in Interest Payments in 2006 to that in 2011?
Provide a succinct answer. 0.81. What is the ratio of the Expenses (in $) of Other expenses in 2006 to that in 2011?
Give a very brief answer. 0.59. What is the ratio of the Expenses (in $) in Salary of employees in 2007 to that in 2008?
Make the answer very short. 0.81. What is the ratio of the Expenses (in $) of Custom duties in 2007 to that in 2008?
Your answer should be very brief. 0.92. What is the ratio of the Expenses (in $) in Interest Payments in 2007 to that in 2008?
Provide a short and direct response. 0.83. What is the ratio of the Expenses (in $) of Other expenses in 2007 to that in 2008?
Offer a terse response. 0.85. What is the ratio of the Expenses (in $) of Salary of employees in 2007 to that in 2009?
Ensure brevity in your answer.  0.73. What is the ratio of the Expenses (in $) of Custom duties in 2007 to that in 2009?
Offer a very short reply. 1.01. What is the ratio of the Expenses (in $) in Interest Payments in 2007 to that in 2009?
Offer a terse response. 0.55. What is the ratio of the Expenses (in $) in Other expenses in 2007 to that in 2009?
Give a very brief answer. 0.69. What is the ratio of the Expenses (in $) in Salary of employees in 2007 to that in 2010?
Make the answer very short. 0.69. What is the ratio of the Expenses (in $) of Custom duties in 2007 to that in 2010?
Your answer should be compact. 0.93. What is the ratio of the Expenses (in $) of Interest Payments in 2007 to that in 2010?
Give a very brief answer. 0.81. What is the ratio of the Expenses (in $) of Other expenses in 2007 to that in 2010?
Provide a short and direct response. 0.74. What is the ratio of the Expenses (in $) of Salary of employees in 2007 to that in 2011?
Ensure brevity in your answer.  0.62. What is the ratio of the Expenses (in $) in Custom duties in 2007 to that in 2011?
Ensure brevity in your answer.  0.96. What is the ratio of the Expenses (in $) in Interest Payments in 2007 to that in 2011?
Your answer should be very brief. 0.86. What is the ratio of the Expenses (in $) of Other expenses in 2007 to that in 2011?
Give a very brief answer. 0.7. What is the ratio of the Expenses (in $) in Salary of employees in 2008 to that in 2009?
Offer a terse response. 0.91. What is the ratio of the Expenses (in $) of Custom duties in 2008 to that in 2009?
Ensure brevity in your answer.  1.1. What is the ratio of the Expenses (in $) of Interest Payments in 2008 to that in 2009?
Keep it short and to the point. 0.67. What is the ratio of the Expenses (in $) in Other expenses in 2008 to that in 2009?
Give a very brief answer. 0.81. What is the ratio of the Expenses (in $) in Salary of employees in 2008 to that in 2010?
Your answer should be very brief. 0.86. What is the ratio of the Expenses (in $) of Custom duties in 2008 to that in 2010?
Provide a succinct answer. 1.01. What is the ratio of the Expenses (in $) in Interest Payments in 2008 to that in 2010?
Offer a very short reply. 0.98. What is the ratio of the Expenses (in $) of Other expenses in 2008 to that in 2010?
Give a very brief answer. 0.86. What is the ratio of the Expenses (in $) in Salary of employees in 2008 to that in 2011?
Provide a succinct answer. 0.77. What is the ratio of the Expenses (in $) of Custom duties in 2008 to that in 2011?
Keep it short and to the point. 1.04. What is the ratio of the Expenses (in $) of Interest Payments in 2008 to that in 2011?
Provide a short and direct response. 1.04. What is the ratio of the Expenses (in $) in Other expenses in 2008 to that in 2011?
Ensure brevity in your answer.  0.82. What is the ratio of the Expenses (in $) of Salary of employees in 2009 to that in 2010?
Give a very brief answer. 0.95. What is the ratio of the Expenses (in $) in Custom duties in 2009 to that in 2010?
Your response must be concise. 0.92. What is the ratio of the Expenses (in $) of Interest Payments in 2009 to that in 2010?
Your answer should be compact. 1.47. What is the ratio of the Expenses (in $) of Other expenses in 2009 to that in 2010?
Your answer should be very brief. 1.06. What is the ratio of the Expenses (in $) in Salary of employees in 2009 to that in 2011?
Make the answer very short. 0.85. What is the ratio of the Expenses (in $) in Custom duties in 2009 to that in 2011?
Offer a very short reply. 0.94. What is the ratio of the Expenses (in $) of Interest Payments in 2009 to that in 2011?
Your answer should be compact. 1.56. What is the ratio of the Expenses (in $) of Other expenses in 2009 to that in 2011?
Your answer should be compact. 1.02. What is the ratio of the Expenses (in $) of Salary of employees in 2010 to that in 2011?
Make the answer very short. 0.9. What is the ratio of the Expenses (in $) of Custom duties in 2010 to that in 2011?
Your answer should be compact. 1.03. What is the ratio of the Expenses (in $) in Interest Payments in 2010 to that in 2011?
Your response must be concise. 1.06. What is the ratio of the Expenses (in $) of Other expenses in 2010 to that in 2011?
Give a very brief answer. 0.96. What is the difference between the highest and the second highest Expenses (in $) of Salary of employees?
Give a very brief answer. 7.79e+09. What is the difference between the highest and the second highest Expenses (in $) in Custom duties?
Provide a succinct answer. 1.80e+08. What is the difference between the highest and the second highest Expenses (in $) of Interest Payments?
Your response must be concise. 6.04e+1. What is the difference between the highest and the second highest Expenses (in $) of Other expenses?
Provide a short and direct response. 7.65e+09. What is the difference between the highest and the lowest Expenses (in $) of Salary of employees?
Offer a terse response. 4.24e+1. What is the difference between the highest and the lowest Expenses (in $) in Custom duties?
Offer a very short reply. 5.44e+09. What is the difference between the highest and the lowest Expenses (in $) of Interest Payments?
Keep it short and to the point. 1.04e+11. What is the difference between the highest and the lowest Expenses (in $) in Other expenses?
Offer a terse response. 2.24e+11. 